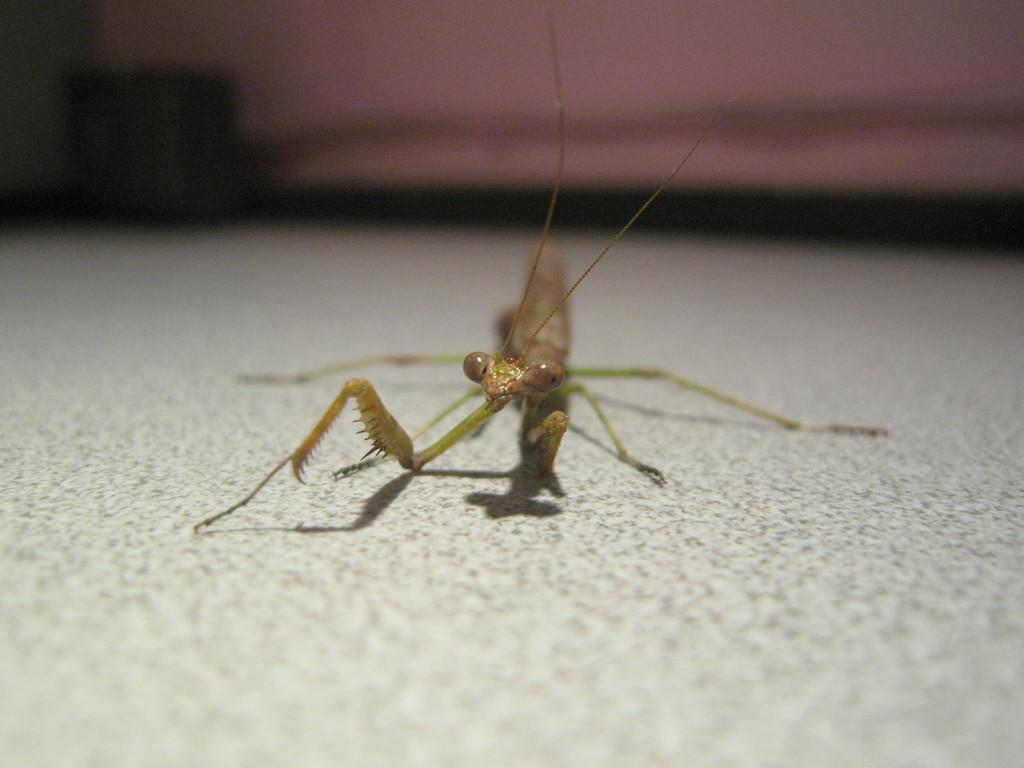Where was the image taken? The image was taken indoors. What can be seen underfoot in the image? There is a floor visible in the image. What type of insect is present on the floor in the image? There is a grasshopper on the floor in the image. What is the result of adding 2 and 3 in the image? There is no addition or mathematical operation present in the image; it features a grasshopper on the floor. What is happening in the back of the image? The image does not show anything happening in the back, as it is taken indoors and the focus is on the grasshopper on the floor. 